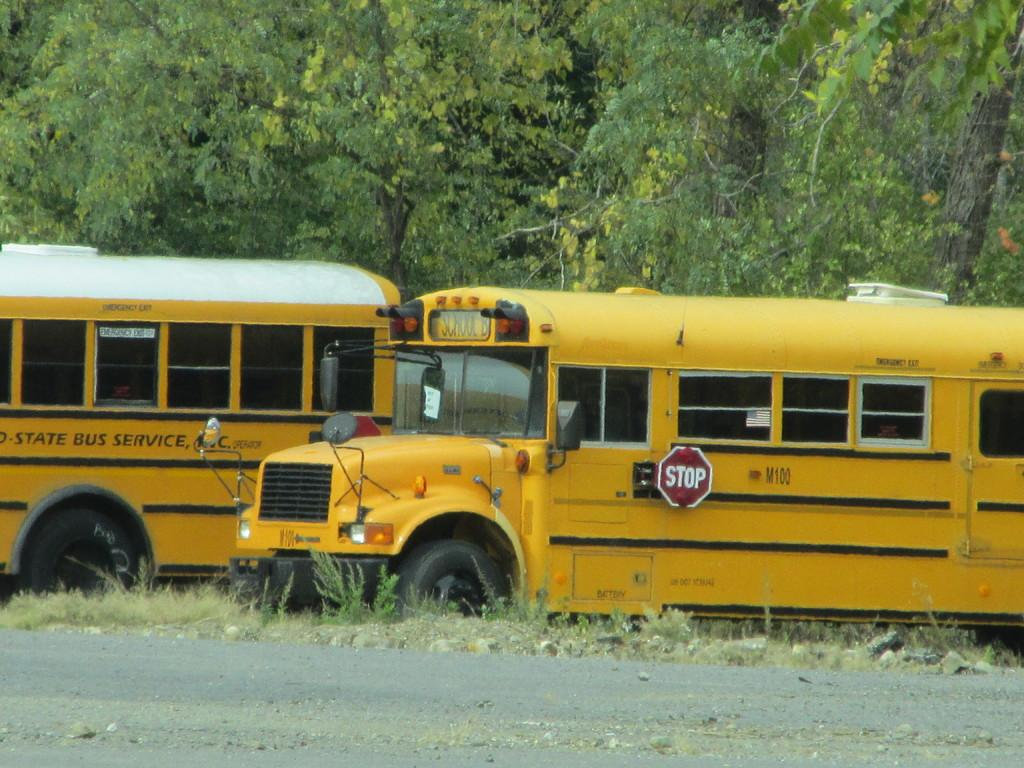What type of vehicles can be seen on the road in the image? There are buses on a road in the image. What can be seen in the background of the image? There are trees in the background of the image. What type of plastic cracker is being eaten by the partner in the image? There is no partner or plastic cracker present in the image. 